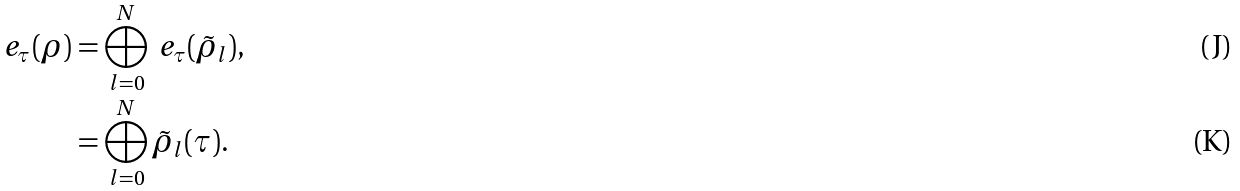Convert formula to latex. <formula><loc_0><loc_0><loc_500><loc_500>\ e _ { \tau } ( \rho ) & = \bigoplus _ { l = 0 } ^ { N } \ e _ { \tau } ( \tilde { \rho } _ { l } ) , \\ & = \bigoplus _ { l = 0 } ^ { N } \tilde { \rho } _ { l } ( \tau ) .</formula> 